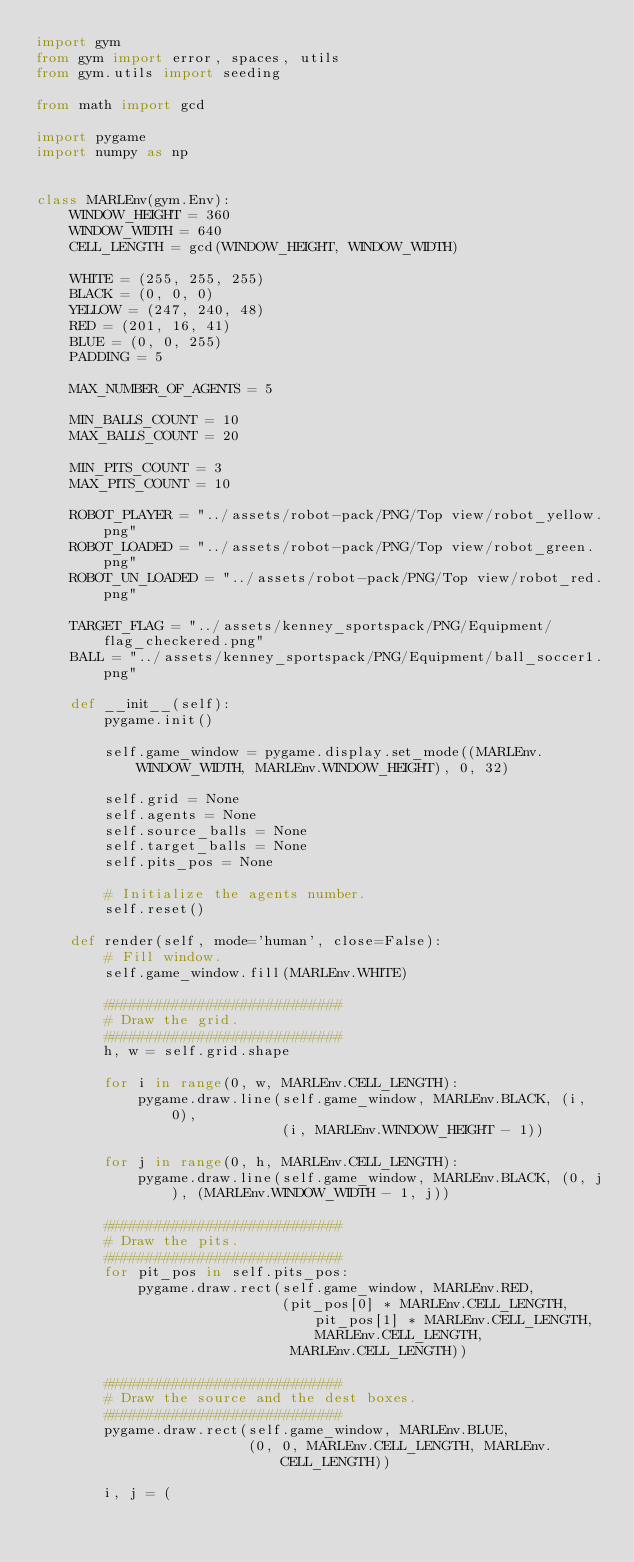Convert code to text. <code><loc_0><loc_0><loc_500><loc_500><_Python_>import gym
from gym import error, spaces, utils
from gym.utils import seeding

from math import gcd

import pygame
import numpy as np


class MARLEnv(gym.Env):
    WINDOW_HEIGHT = 360
    WINDOW_WIDTH = 640
    CELL_LENGTH = gcd(WINDOW_HEIGHT, WINDOW_WIDTH)

    WHITE = (255, 255, 255)
    BLACK = (0, 0, 0)
    YELLOW = (247, 240, 48)
    RED = (201, 16, 41)
    BLUE = (0, 0, 255)
    PADDING = 5

    MAX_NUMBER_OF_AGENTS = 5

    MIN_BALLS_COUNT = 10
    MAX_BALLS_COUNT = 20

    MIN_PITS_COUNT = 3
    MAX_PITS_COUNT = 10

    ROBOT_PLAYER = "../assets/robot-pack/PNG/Top view/robot_yellow.png"
    ROBOT_LOADED = "../assets/robot-pack/PNG/Top view/robot_green.png"
    ROBOT_UN_LOADED = "../assets/robot-pack/PNG/Top view/robot_red.png"

    TARGET_FLAG = "../assets/kenney_sportspack/PNG/Equipment/flag_checkered.png"
    BALL = "../assets/kenney_sportspack/PNG/Equipment/ball_soccer1.png"

    def __init__(self):
        pygame.init()

        self.game_window = pygame.display.set_mode((MARLEnv.WINDOW_WIDTH, MARLEnv.WINDOW_HEIGHT), 0, 32)

        self.grid = None
        self.agents = None
        self.source_balls = None
        self.target_balls = None
        self.pits_pos = None

        # Initialize the agents number.
        self.reset()

    def render(self, mode='human', close=False):
        # Fill window.
        self.game_window.fill(MARLEnv.WHITE)

        ############################
        # Draw the grid.
        ############################
        h, w = self.grid.shape

        for i in range(0, w, MARLEnv.CELL_LENGTH):
            pygame.draw.line(self.game_window, MARLEnv.BLACK, (i, 0),
                             (i, MARLEnv.WINDOW_HEIGHT - 1))

        for j in range(0, h, MARLEnv.CELL_LENGTH):
            pygame.draw.line(self.game_window, MARLEnv.BLACK, (0, j), (MARLEnv.WINDOW_WIDTH - 1, j))

        ############################
        # Draw the pits.
        ############################
        for pit_pos in self.pits_pos:
            pygame.draw.rect(self.game_window, MARLEnv.RED,
                             (pit_pos[0] * MARLEnv.CELL_LENGTH, pit_pos[1] * MARLEnv.CELL_LENGTH, MARLEnv.CELL_LENGTH,
                              MARLEnv.CELL_LENGTH))

        ############################
        # Draw the source and the dest boxes.
        ############################
        pygame.draw.rect(self.game_window, MARLEnv.BLUE,
                         (0, 0, MARLEnv.CELL_LENGTH, MARLEnv.CELL_LENGTH))

        i, j = (</code> 